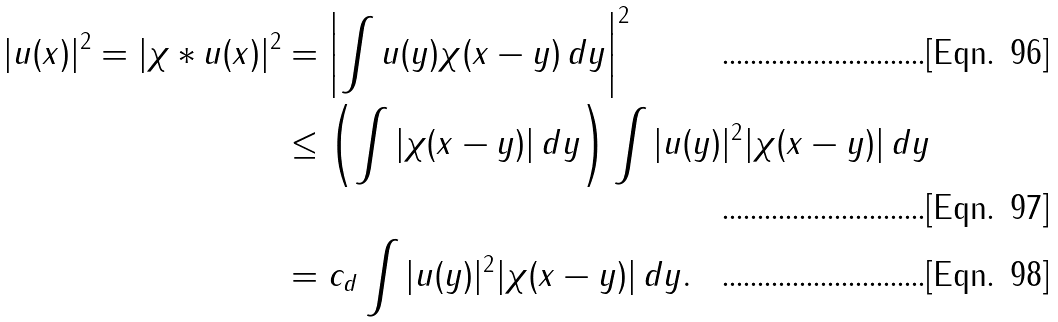Convert formula to latex. <formula><loc_0><loc_0><loc_500><loc_500>| u ( x ) | ^ { 2 } = | \chi \ast u ( x ) | ^ { 2 } & = \left | \int u ( y ) \chi ( x - y ) \, d y \right | ^ { 2 } \\ & \leq \left ( \int | \chi ( x - y ) | \, d y \right ) \int | u ( y ) | ^ { 2 } | \chi ( x - y ) | \, d y \\ & = c _ { d } \int | u ( y ) | ^ { 2 } | \chi ( x - y ) | \, d y .</formula> 